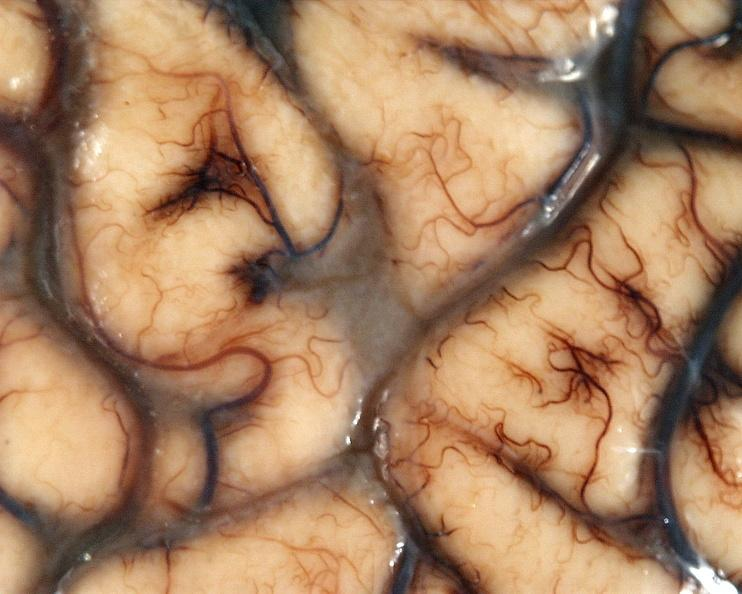does spleen show brain, cryptococcal meningitis?
Answer the question using a single word or phrase. No 